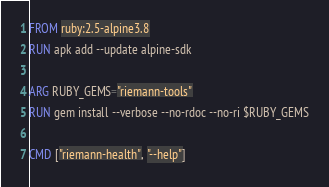<code> <loc_0><loc_0><loc_500><loc_500><_Dockerfile_>FROM ruby:2.5-alpine3.8
RUN apk add --update alpine-sdk

ARG RUBY_GEMS="riemann-tools"
RUN gem install --verbose --no-rdoc --no-ri $RUBY_GEMS

CMD ["riemann-health", "--help"]
</code> 